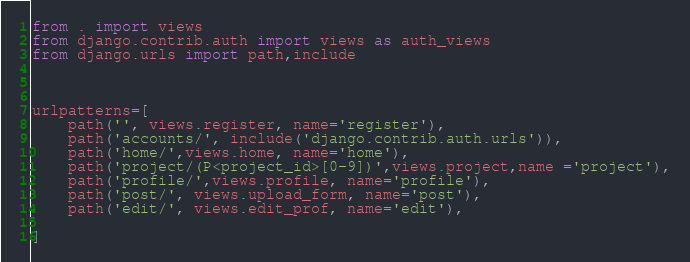<code> <loc_0><loc_0><loc_500><loc_500><_Python_>from . import views
from django.contrib.auth import views as auth_views
from django.urls import path,include



urlpatterns=[
    path('', views.register, name='register'),
    path('accounts/', include('django.contrib.auth.urls')),
    path('home/',views.home, name='home'),
    path('project/(P<project_id>[0-9])',views.project,name ='project'),
    path('profile/',views.profile, name='profile'),
    path('post/', views.upload_form, name='post'),
    path('edit/', views.edit_prof, name='edit'),

]
</code> 